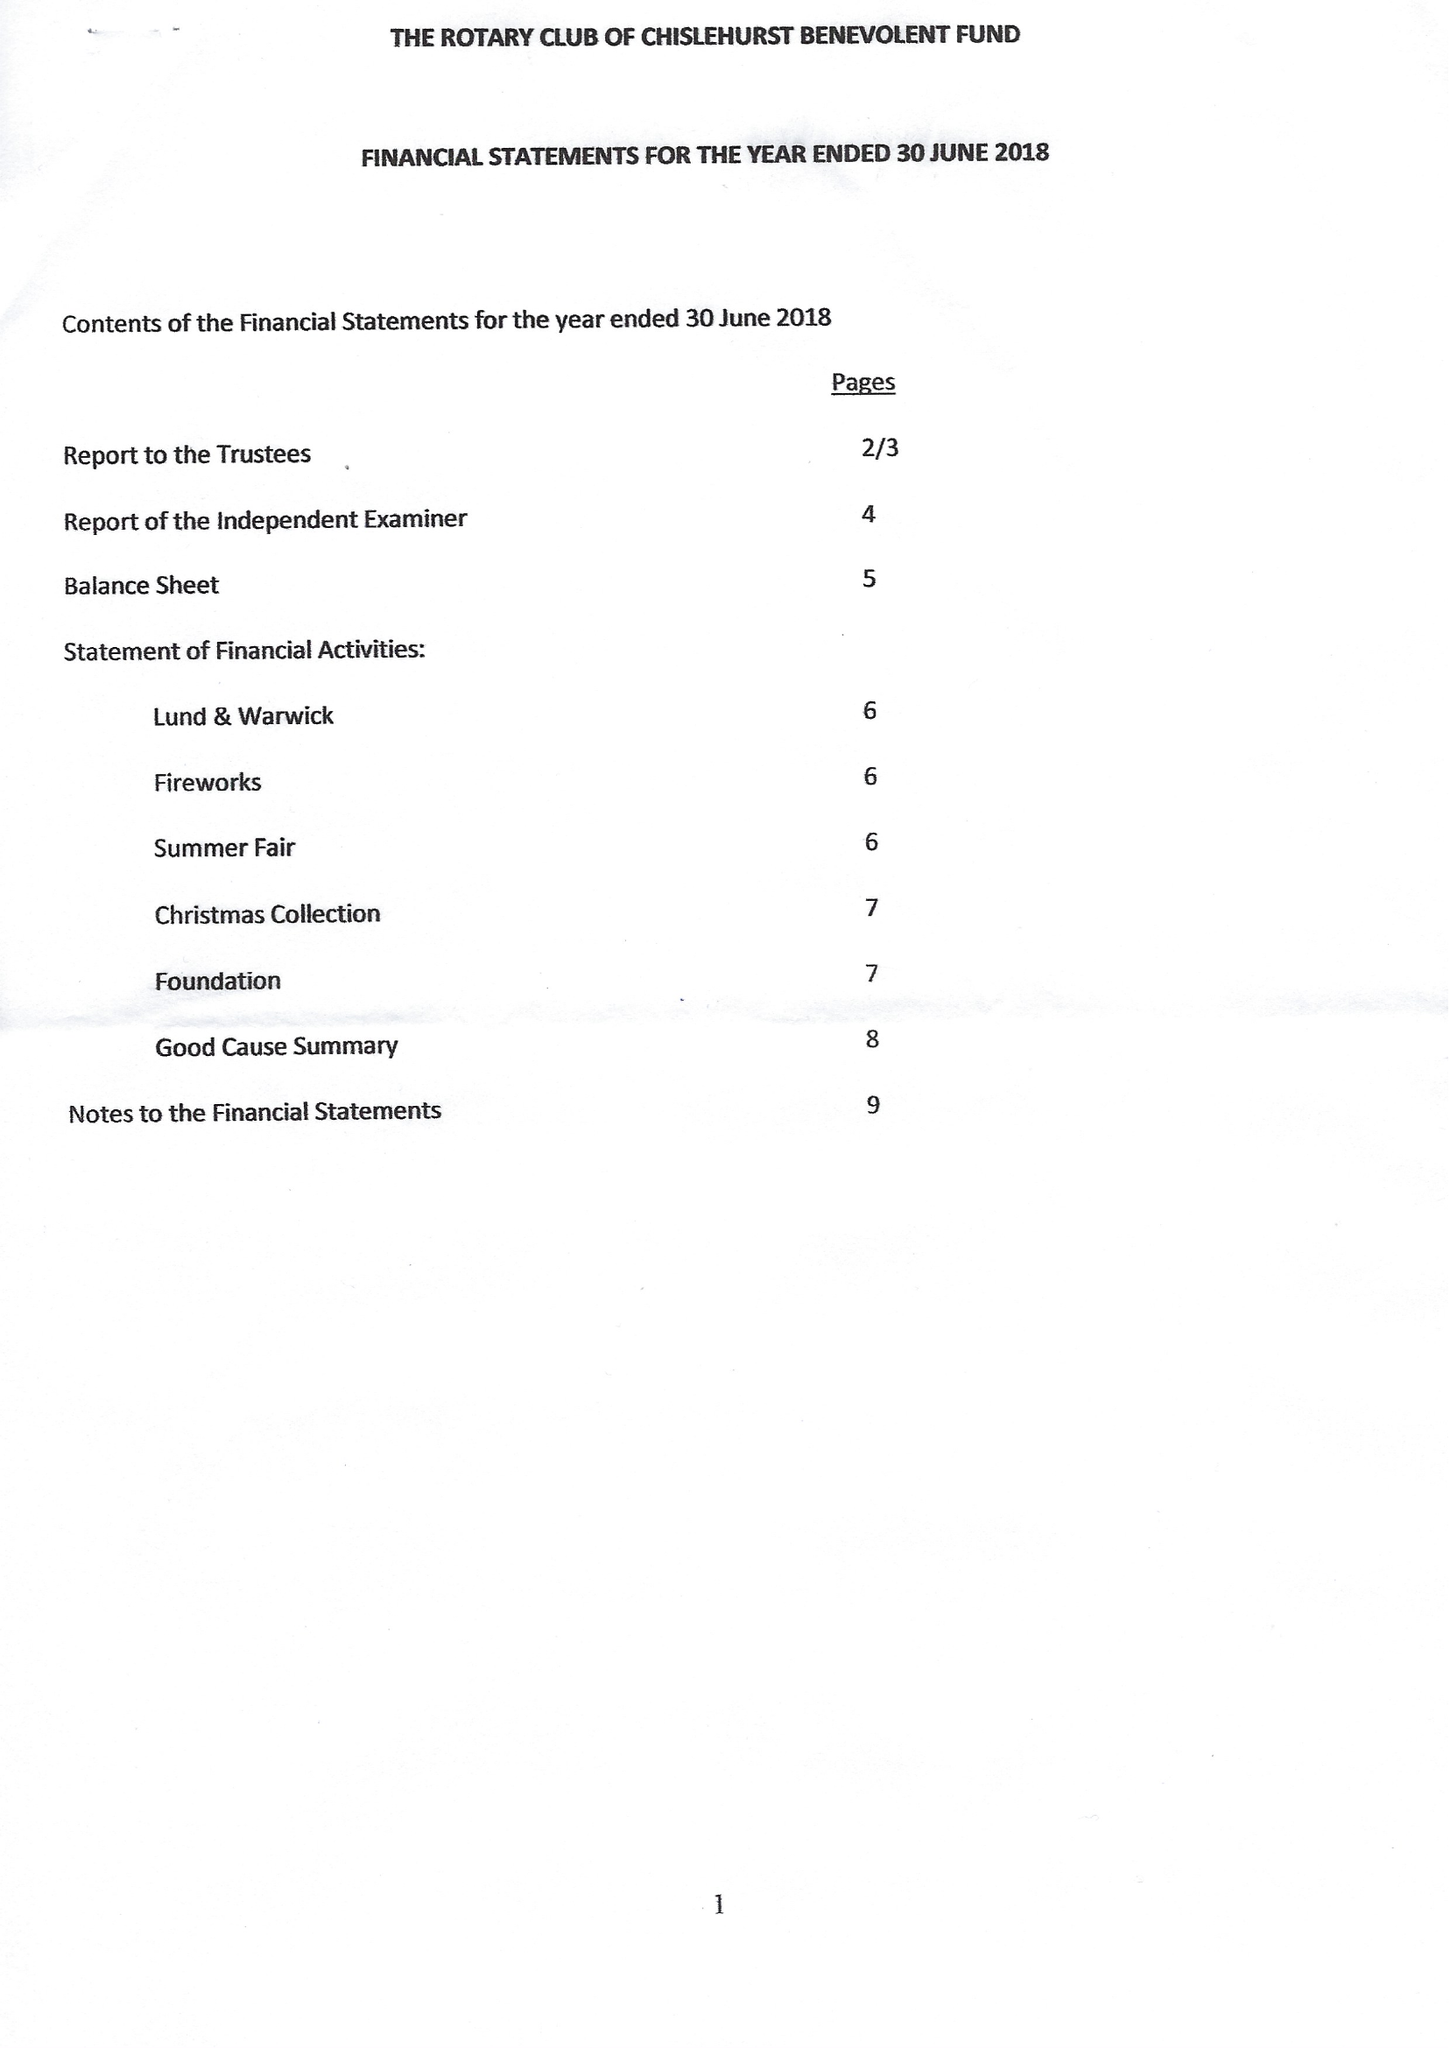What is the value for the report_date?
Answer the question using a single word or phrase. 2018-06-30 